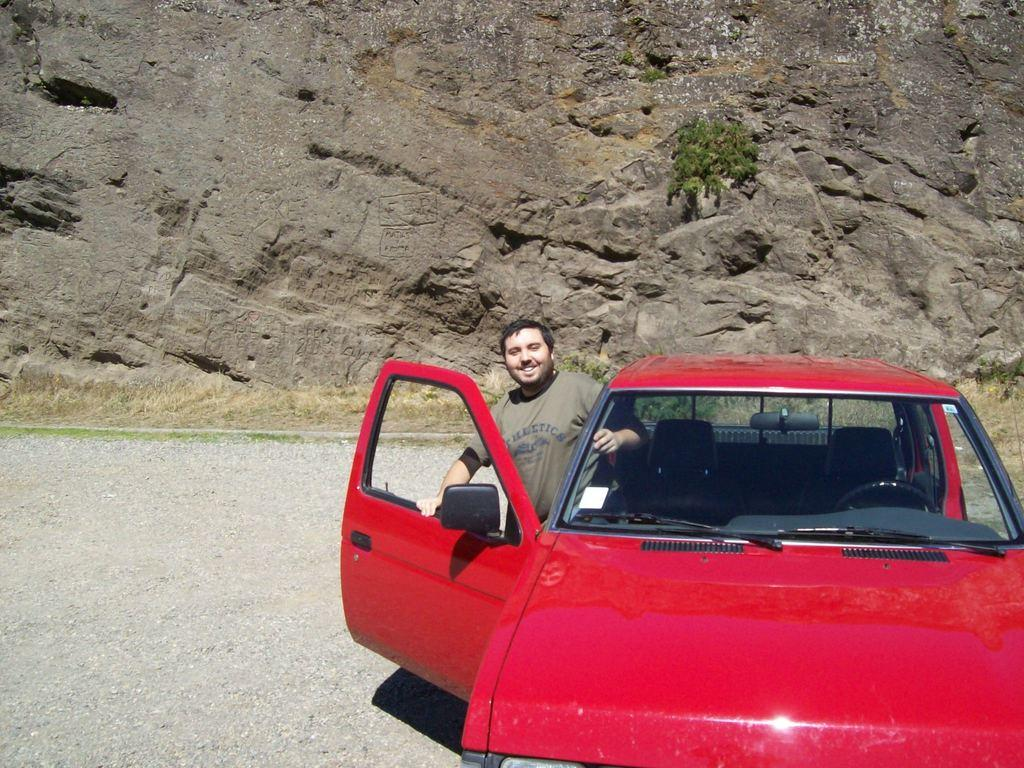Who is present in the image? There is a person in the image. What is the person doing or standing near in the image? The person is beside a car. What is visible in the background of the image? The car is in front of a hill. What type of pot is the person's aunt holding in the image? There is no aunt or pot present in the image. How does the person walk towards the car in the image? The person is not walking towards the car in the image; they are already beside it. 